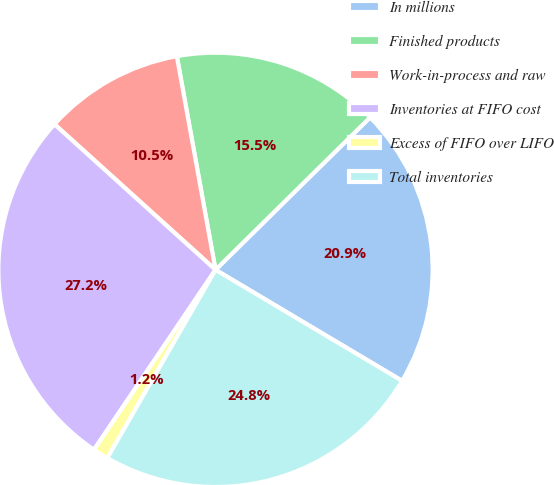Convert chart. <chart><loc_0><loc_0><loc_500><loc_500><pie_chart><fcel>In millions<fcel>Finished products<fcel>Work-in-process and raw<fcel>Inventories at FIFO cost<fcel>Excess of FIFO over LIFO<fcel>Total inventories<nl><fcel>20.93%<fcel>15.46%<fcel>10.45%<fcel>27.24%<fcel>1.15%<fcel>24.76%<nl></chart> 